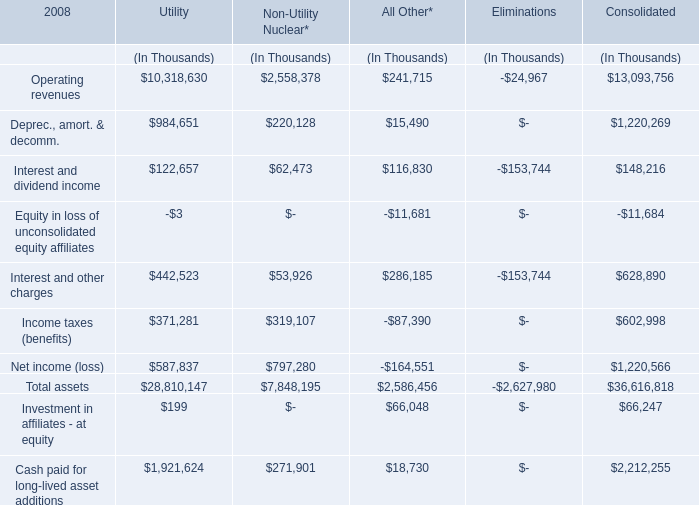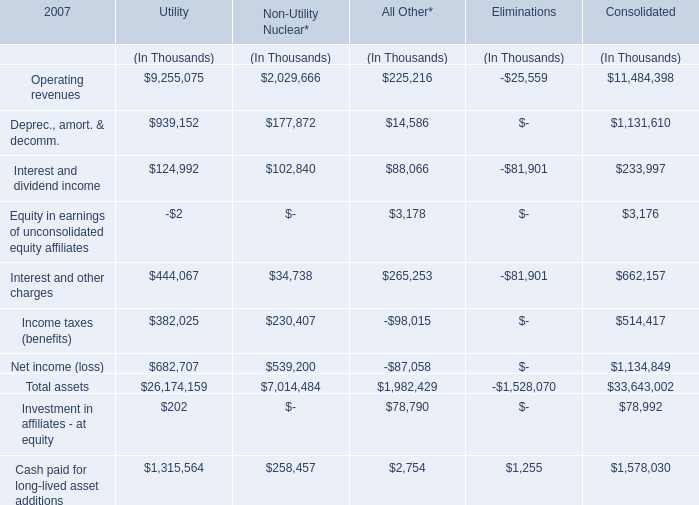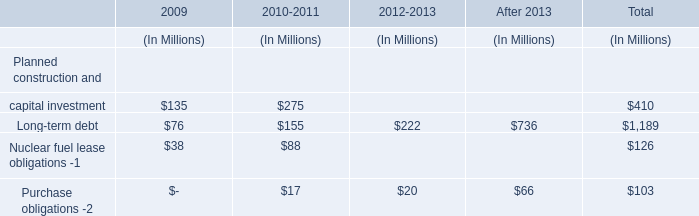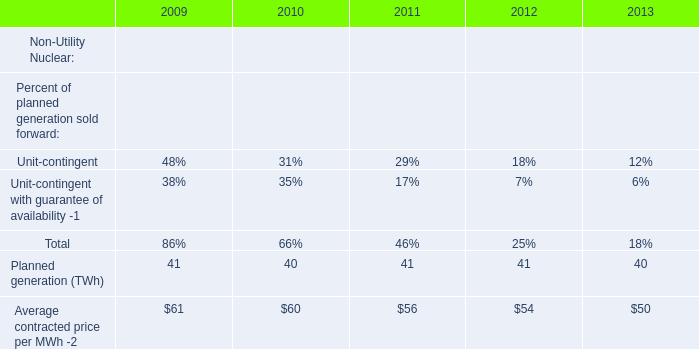What is the ratio of all Operating revenues that are in the range of 0 and 10000000 thousand to the sum of Operating revenues, in 2007? 
Computations: (((9255075 + 2029666) + 225216) / ((((9255075 + 2029666) + 225216) + -25559) + 11484398))
Answer: 0.50111. 